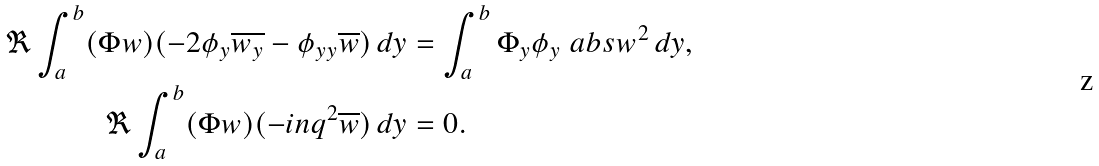<formula> <loc_0><loc_0><loc_500><loc_500>\Re \int _ { a } ^ { b } ( \Phi w ) ( - 2 \phi _ { y } \overline { w _ { y } } - \phi _ { y y } \overline { w } ) \, d y & = \int _ { a } ^ { b } \Phi _ { y } \phi _ { y } \ a b s w ^ { 2 } \, d y , \\ \Re \int _ { a } ^ { b } ( \Phi w ) ( - i n q ^ { 2 } \overline { w } ) \, d y & = 0 .</formula> 